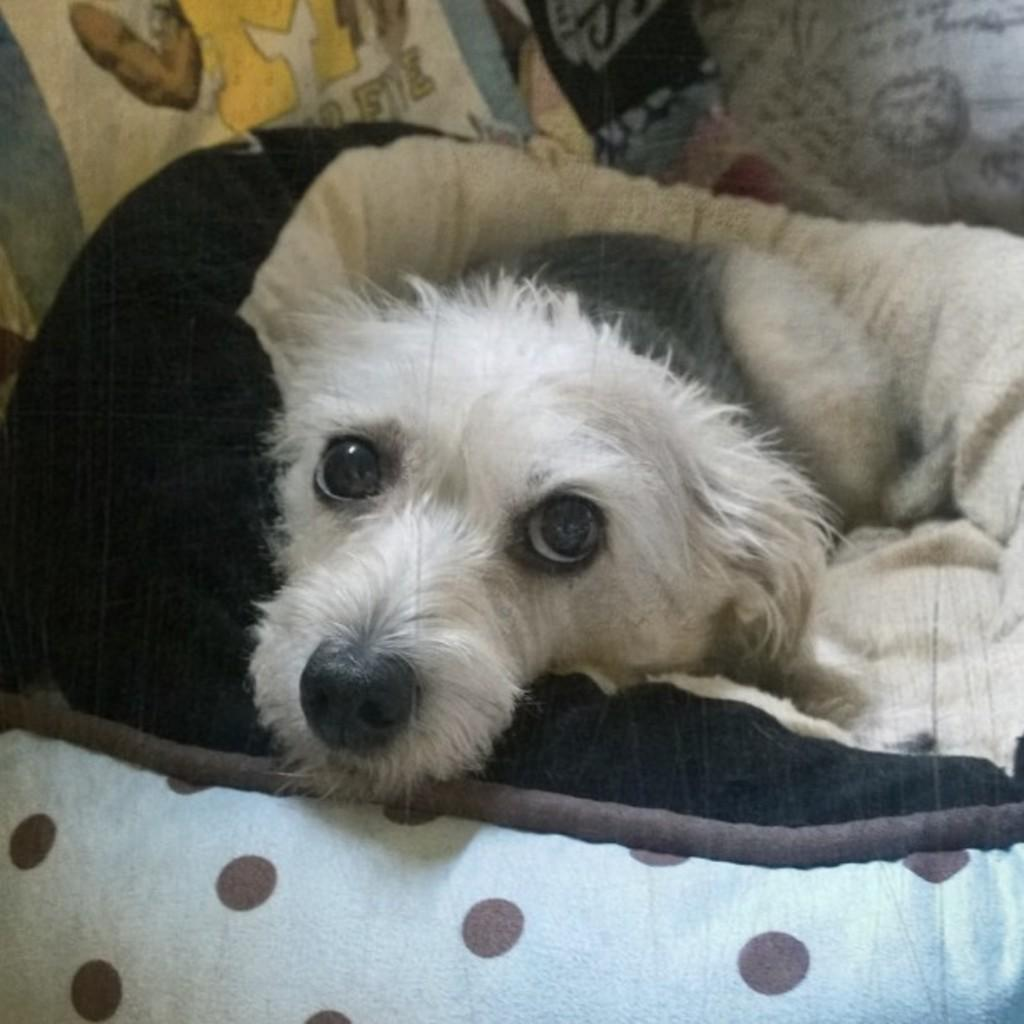What animal can be seen in the image? There is a dog in the image. What is the dog laying on? The dog is laying on a cloth. Can you describe any other objects in the background of the image? There is a pillow in the background of the image. How many bikes are parked next to the dog in the image? There are no bikes present in the image; it only features a dog laying on a cloth with a pillow in the background. 